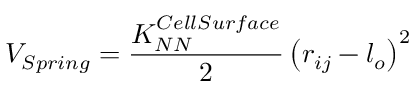<formula> <loc_0><loc_0><loc_500><loc_500>V _ { S p r i n g } = \frac { K _ { N N } ^ { C e l l S u r f a c e } } { 2 } \left ( r _ { i j } - l _ { o } \right ) ^ { 2 }</formula> 